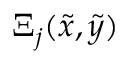Convert formula to latex. <formula><loc_0><loc_0><loc_500><loc_500>\Xi _ { j } ( \tilde { x } , \tilde { y } )</formula> 